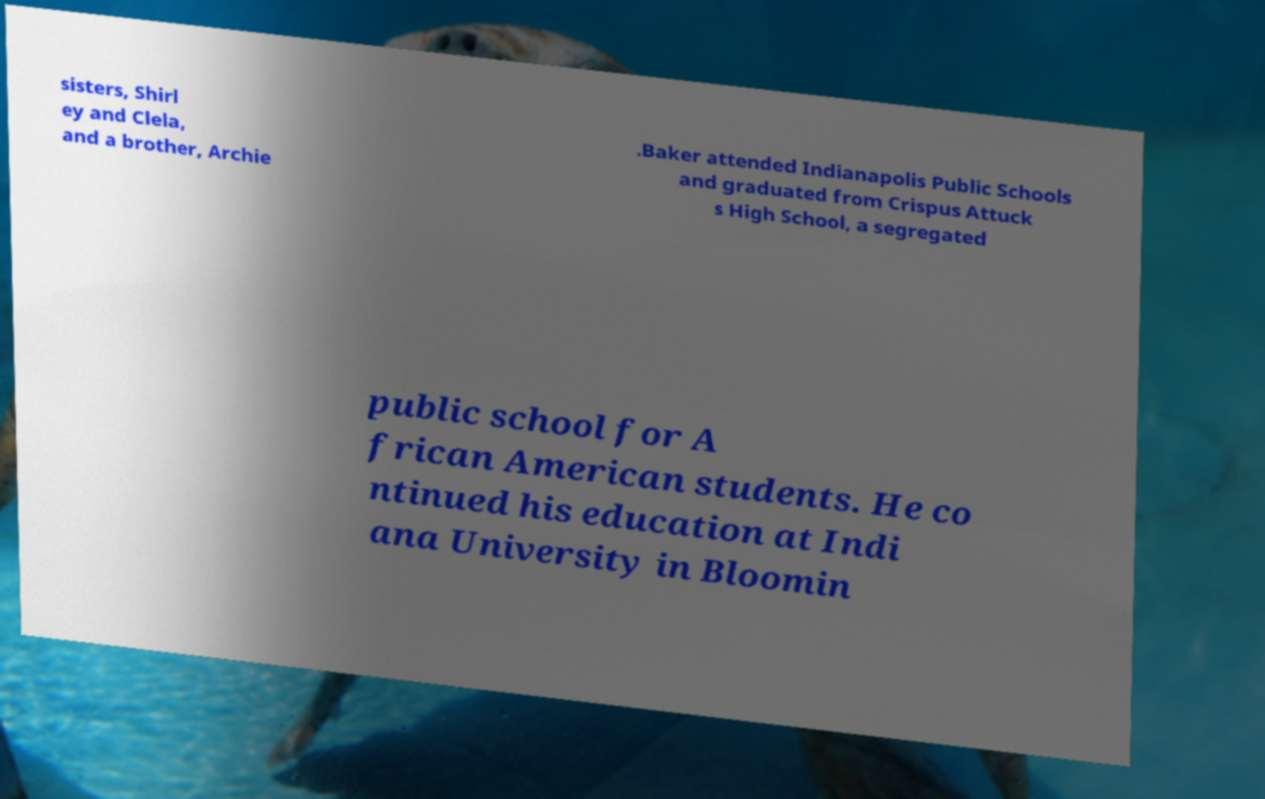Could you assist in decoding the text presented in this image and type it out clearly? sisters, Shirl ey and Clela, and a brother, Archie .Baker attended Indianapolis Public Schools and graduated from Crispus Attuck s High School, a segregated public school for A frican American students. He co ntinued his education at Indi ana University in Bloomin 